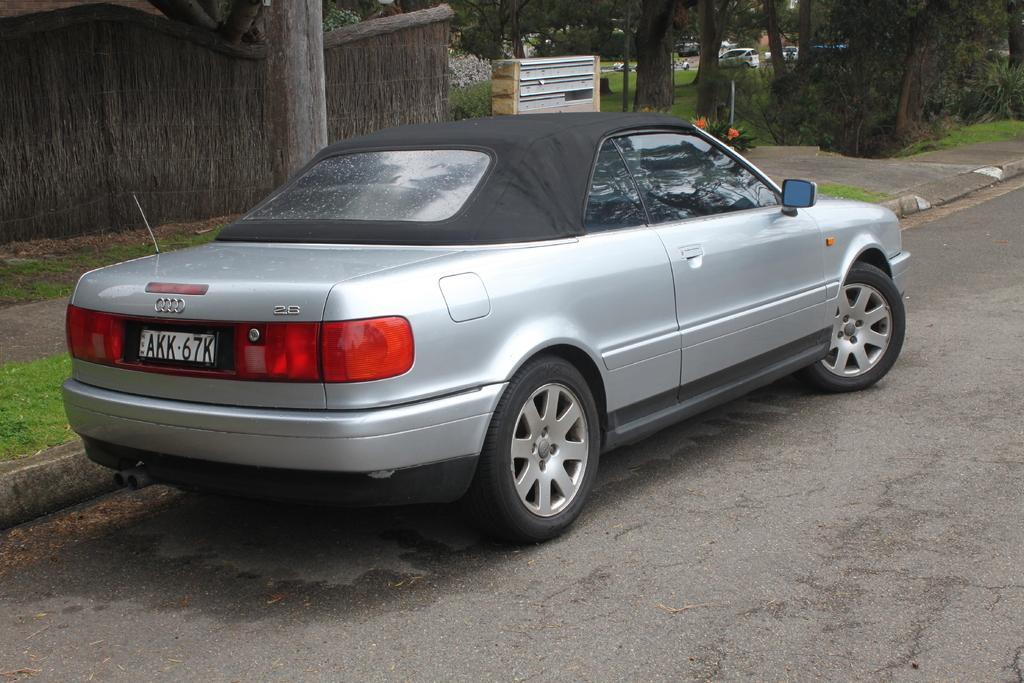Could you give a brief overview of what you see in this image? In the foreground of this image, there is a car on the road. In the background, there is a wall, trunk, an object and the side path. 